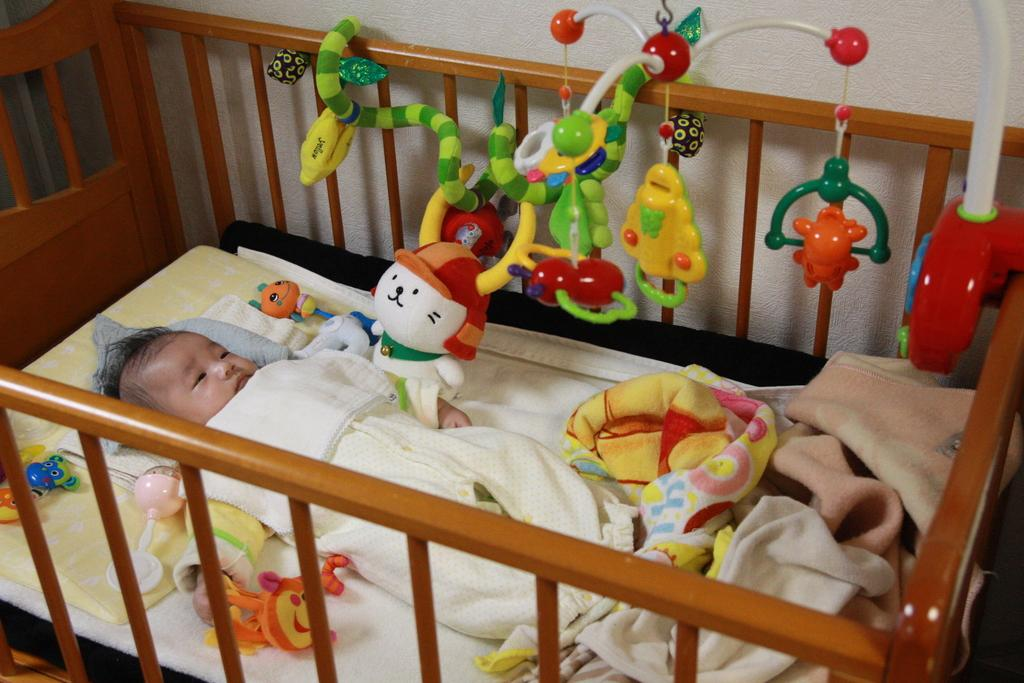What is the main subject of the image? There is a baby sleeping in the crib. What color is the crib? The crib is brown in color. What items are present in the crib with the baby? There are clothes and toys in the crib. What color is the wall in the image? The wall is white in color. What type of seed is being used to make the eggnog in the image? There is no seed or eggnog present in the image; it features a baby sleeping in a brown crib with clothes and toys, and a white wall. 